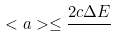Convert formula to latex. <formula><loc_0><loc_0><loc_500><loc_500>< a > \leq \frac { 2 c \Delta E } { }</formula> 